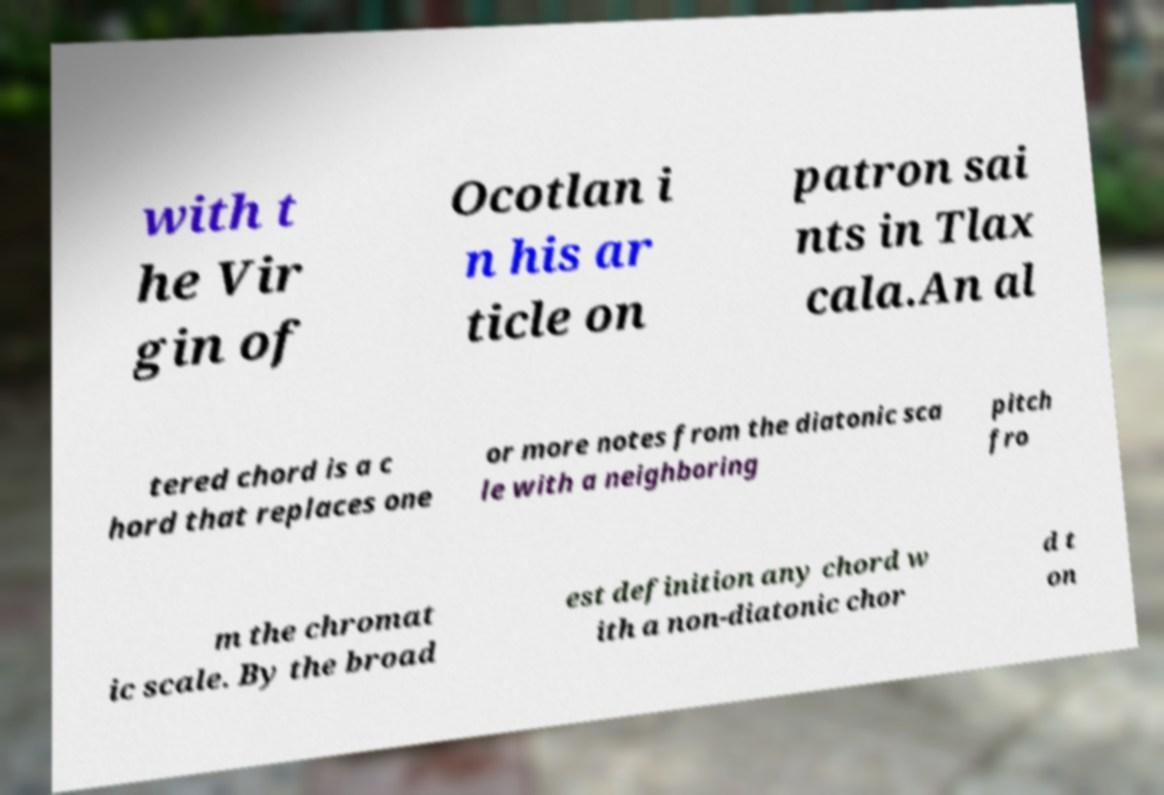I need the written content from this picture converted into text. Can you do that? with t he Vir gin of Ocotlan i n his ar ticle on patron sai nts in Tlax cala.An al tered chord is a c hord that replaces one or more notes from the diatonic sca le with a neighboring pitch fro m the chromat ic scale. By the broad est definition any chord w ith a non-diatonic chor d t on 